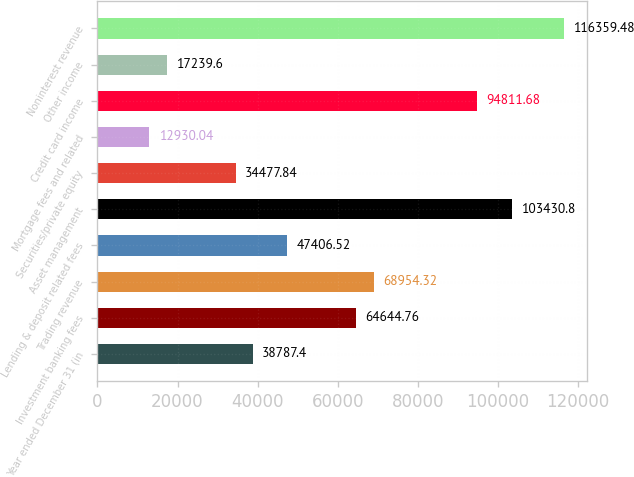Convert chart. <chart><loc_0><loc_0><loc_500><loc_500><bar_chart><fcel>Year ended December 31 (in<fcel>Investment banking fees<fcel>Trading revenue<fcel>Lending & deposit related fees<fcel>Asset management<fcel>Securities/private equity<fcel>Mortgage fees and related<fcel>Credit card income<fcel>Other income<fcel>Noninterest revenue<nl><fcel>38787.4<fcel>64644.8<fcel>68954.3<fcel>47406.5<fcel>103431<fcel>34477.8<fcel>12930<fcel>94811.7<fcel>17239.6<fcel>116359<nl></chart> 